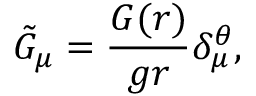<formula> <loc_0><loc_0><loc_500><loc_500>\tilde { G } _ { \mu } = \frac { G ( r ) } { g r } \delta _ { \mu } ^ { \theta } ,</formula> 